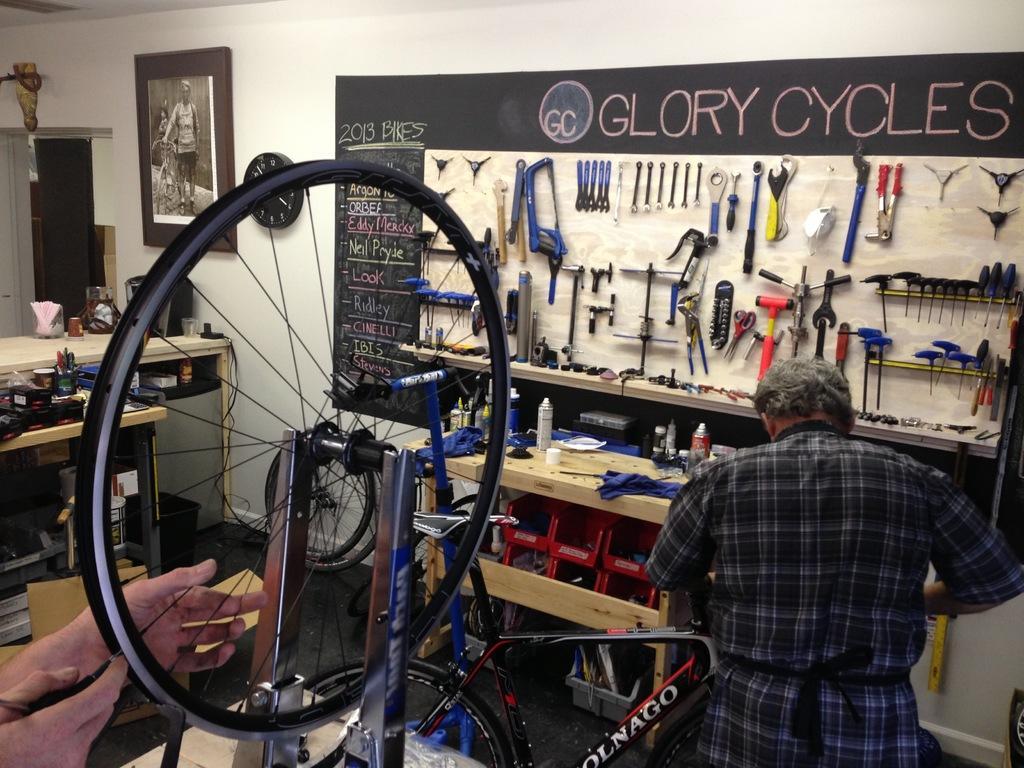Can you describe this image briefly? In the image I can see few tools are attached to the board. The frame, clock and the board is attached to the wall. I can see few objects, bottles, few cloth pieces on the tables. In front I can see few people and the bicycle wheels. The wall is in white color. 